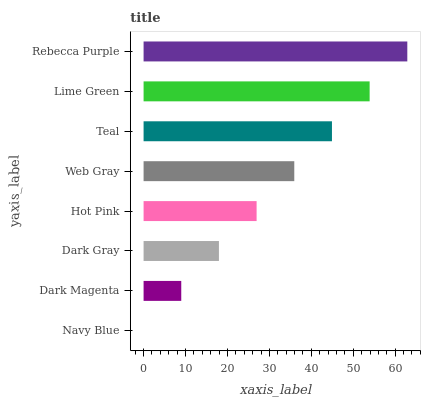Is Navy Blue the minimum?
Answer yes or no. Yes. Is Rebecca Purple the maximum?
Answer yes or no. Yes. Is Dark Magenta the minimum?
Answer yes or no. No. Is Dark Magenta the maximum?
Answer yes or no. No. Is Dark Magenta greater than Navy Blue?
Answer yes or no. Yes. Is Navy Blue less than Dark Magenta?
Answer yes or no. Yes. Is Navy Blue greater than Dark Magenta?
Answer yes or no. No. Is Dark Magenta less than Navy Blue?
Answer yes or no. No. Is Web Gray the high median?
Answer yes or no. Yes. Is Hot Pink the low median?
Answer yes or no. Yes. Is Rebecca Purple the high median?
Answer yes or no. No. Is Dark Magenta the low median?
Answer yes or no. No. 